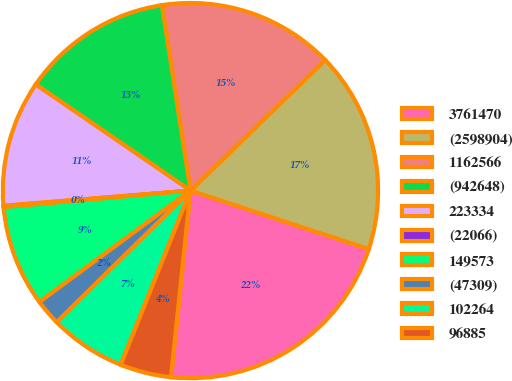<chart> <loc_0><loc_0><loc_500><loc_500><pie_chart><fcel>3761470<fcel>(2598904)<fcel>1162566<fcel>(942648)<fcel>223334<fcel>(22066)<fcel>149573<fcel>(47309)<fcel>102264<fcel>96885<nl><fcel>21.61%<fcel>17.31%<fcel>15.16%<fcel>13.01%<fcel>10.86%<fcel>0.11%<fcel>8.71%<fcel>2.26%<fcel>6.56%<fcel>4.41%<nl></chart> 